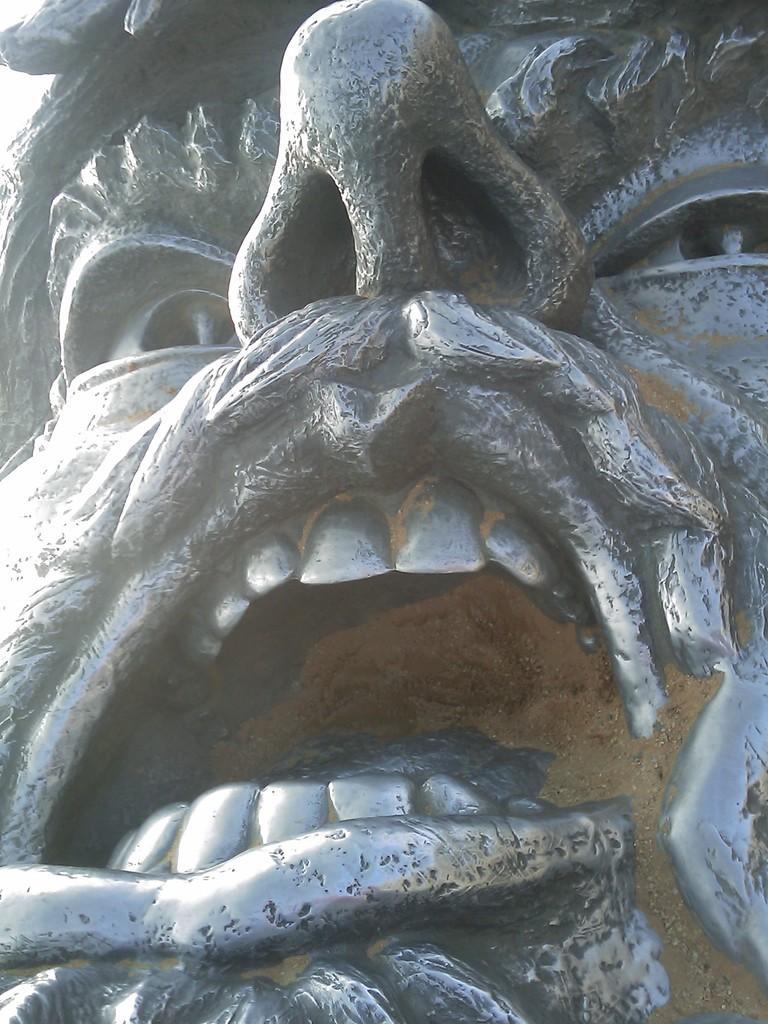Describe this image in one or two sentences. In the center of the image, we can see a sculpture. 